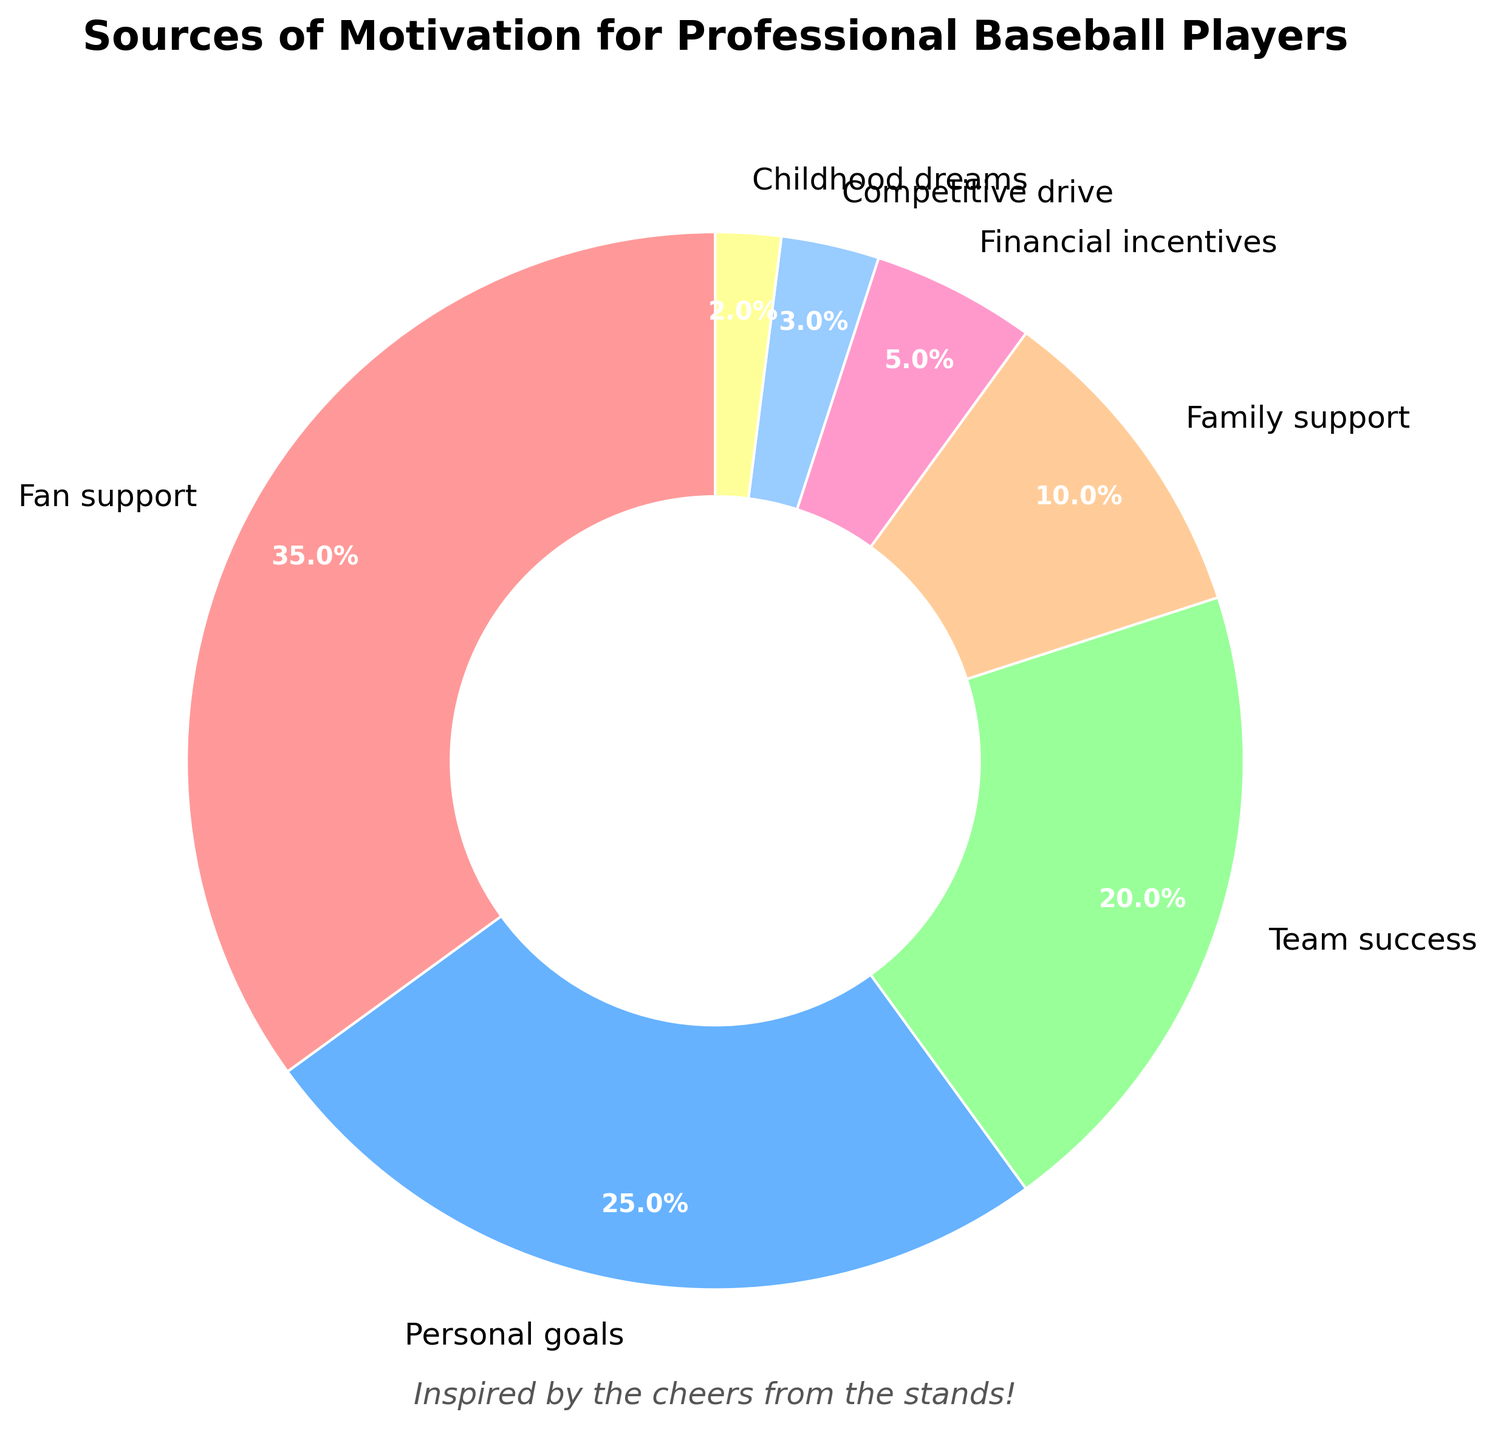what is the largest source of motivation for professional baseball players? According to the pie chart, the largest portion of the chart is dedicated to "Fan support" at 35%.
Answer: Fan support Which source of motivation is the least significant? The smallest section of the pie chart is labeled "Childhood dreams," accounting for 2% of the total.
Answer: Childhood dreams What percentage of players are motivated by Family support and Financial incentives combined? The pie chart shows Family support at 10% and Financial incentives at 5%. Summing these two percentages gives 10% + 5% = 15%.
Answer: 15% Is team success a more significant source of motivation than personal goals? The pie chart indicates that Personal goals account for 25% and Team success accounts for 20%. Since 25% is greater than 20%, Personal goals are more significant than Team success.
Answer: No How many categories have a larger percentage than Competitive drive? Competitive drive is 3%. The categories larger than 3% are Fan support (35%), Personal goals (25%), Team success (20%), Family support (10%), and Financial incentives (5%). There are 5 such categories.
Answer: 5 What is the difference in percentage between the highest and lowest sources of motivation? The highest percentage is for Fan support at 35% and the lowest is for Childhood dreams at 2%. The difference is 35% - 2% = 33%.
Answer: 33% What percentage of players are motivated by Personal goals, Team success, and Family support combined? Personal goals are 25%, Team success is 20%, and Family support is 10%. Summing these percentages, we have 25% + 20% + 10% = 55%.
Answer: 55% Which is more, the combined percentage of Fan support and Childhood dreams or the combined percentage of Financial incentives and Competitive drive? Fan support and Childhood dreams together are 35% + 2% = 37%, while Financial incentives and Competitive drive together are 5% + 3% = 8%. 37% is greater than 8%.
Answer: Fan support and Childhood dreams Is the percentage of players motivated by their Childhood dreams less than or equal to that motivated by Financial incentives? Yes, the pie chart shows Childhood dreams at 2% and Financial incentives at 5%. Since 2% is less than 5%, Childhood dreams are less than Financial incentives.
Answer: Yes 